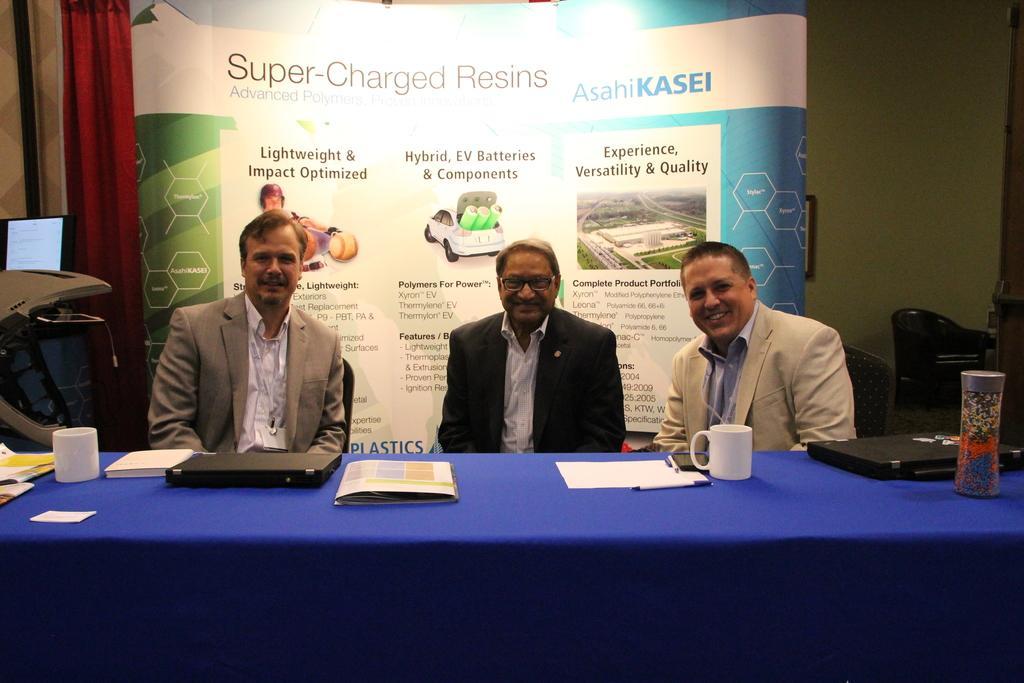Please provide a concise description of this image. In this image we can see three persons sitting. There is a platform. On that there is a bottle, cups, books, laptops and some other items. In the back there is a banner. And there is a curtain. In the background there is a wall. 